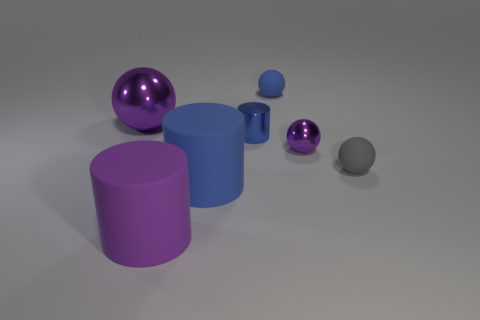There is a purple metallic object that is the same size as the gray thing; what is its shape?
Provide a succinct answer. Sphere. How many things are either metal cylinders that are in front of the small blue ball or gray spheres?
Ensure brevity in your answer.  2. Do the large shiny sphere and the tiny metallic sphere have the same color?
Your answer should be compact. Yes. There is a blue rubber thing that is in front of the tiny purple metal ball; what is its size?
Offer a very short reply. Large. Is there a gray rubber sphere that has the same size as the shiny cylinder?
Offer a very short reply. Yes. Do the blue cylinder behind the gray ball and the big purple metallic object have the same size?
Your response must be concise. No. What size is the blue shiny thing?
Offer a terse response. Small. What is the color of the rubber ball in front of the large purple object behind the big blue cylinder in front of the blue rubber sphere?
Offer a terse response. Gray. There is a small ball that is to the left of the tiny purple metal sphere; does it have the same color as the metallic cylinder?
Provide a short and direct response. Yes. What number of large objects are left of the large blue rubber cylinder and behind the purple rubber object?
Make the answer very short. 1. 